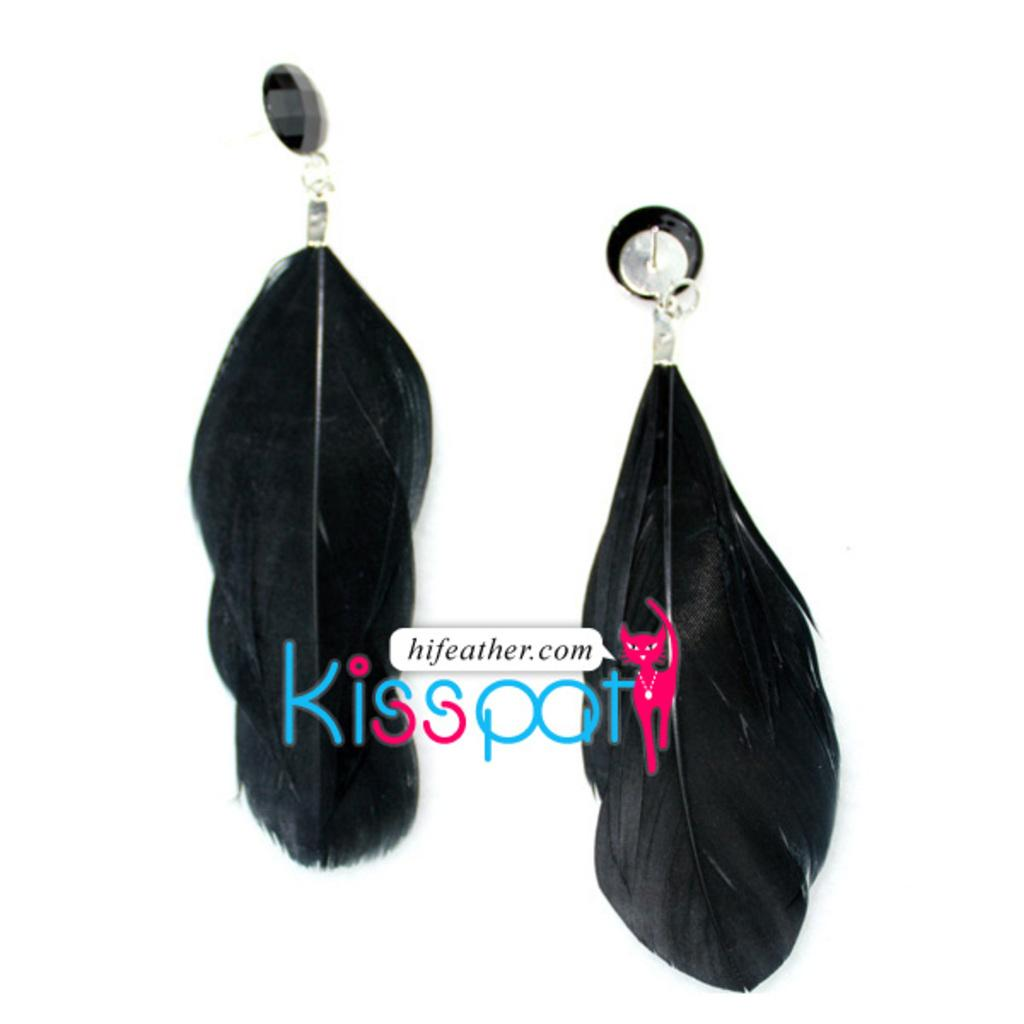What type of accessory is present in the image? There is a set of earrings in the image. Can you describe the earrings in more detail? Unfortunately, the image does not provide enough detail to describe the earrings further. How many yams are being held by the person wearing the earrings in the image? There is no person wearing the earrings in the image, nor are there any yams present. 